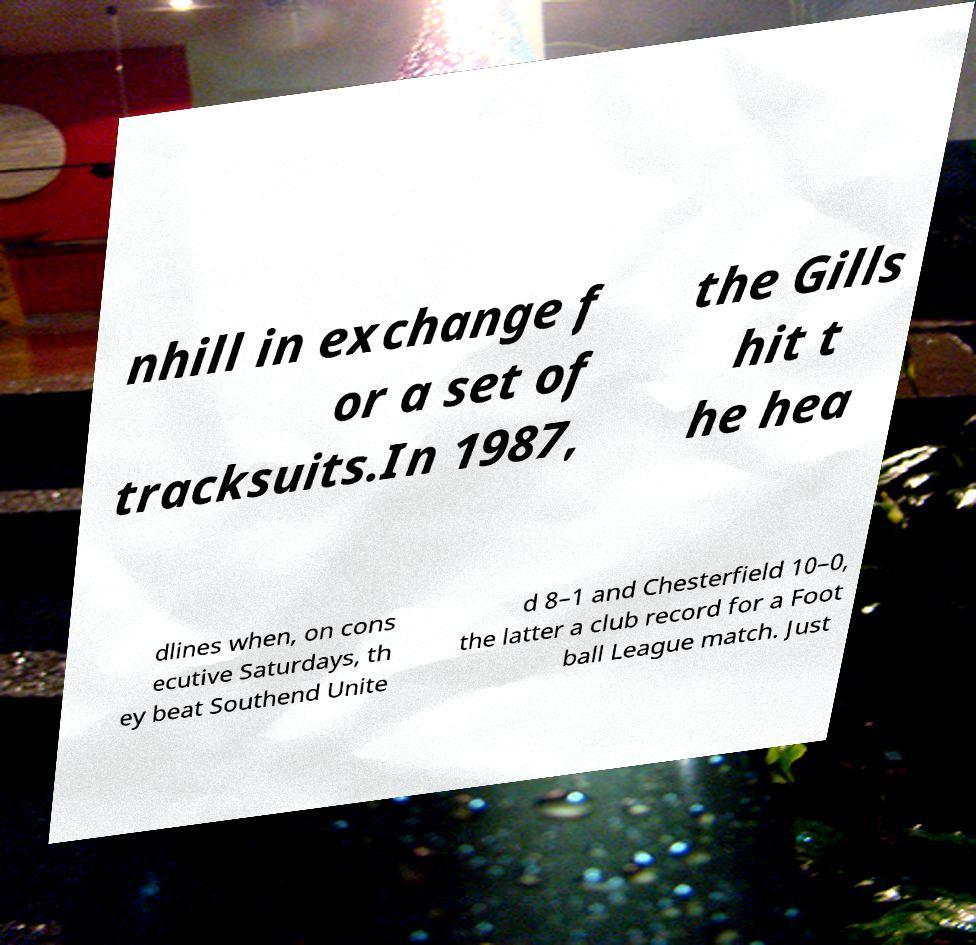I need the written content from this picture converted into text. Can you do that? nhill in exchange f or a set of tracksuits.In 1987, the Gills hit t he hea dlines when, on cons ecutive Saturdays, th ey beat Southend Unite d 8–1 and Chesterfield 10–0, the latter a club record for a Foot ball League match. Just 